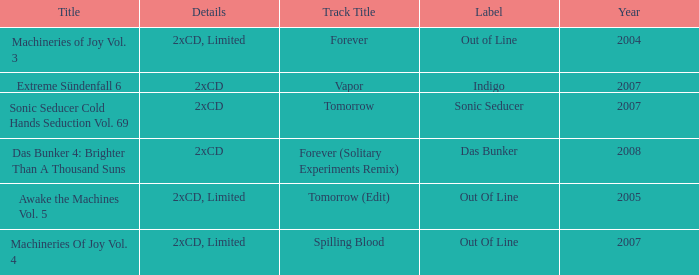Which label has a year older than 2004 and a 2xcd detail as well as the sonic seducer cold hands seduction vol. 69 title? Sonic Seducer. 